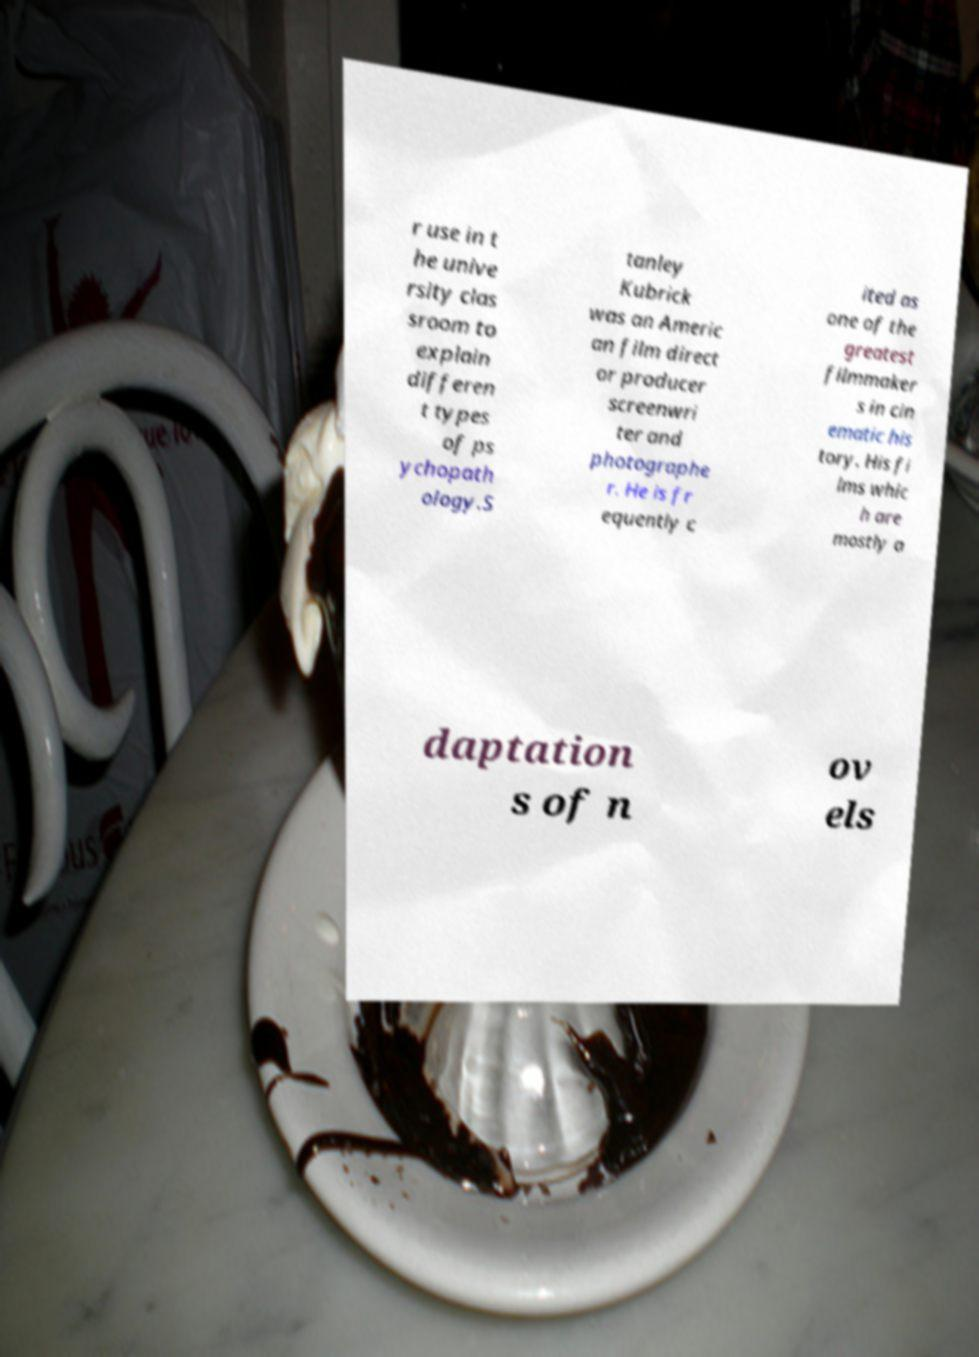Can you accurately transcribe the text from the provided image for me? r use in t he unive rsity clas sroom to explain differen t types of ps ychopath ology.S tanley Kubrick was an Americ an film direct or producer screenwri ter and photographe r. He is fr equently c ited as one of the greatest filmmaker s in cin ematic his tory. His fi lms whic h are mostly a daptation s of n ov els 